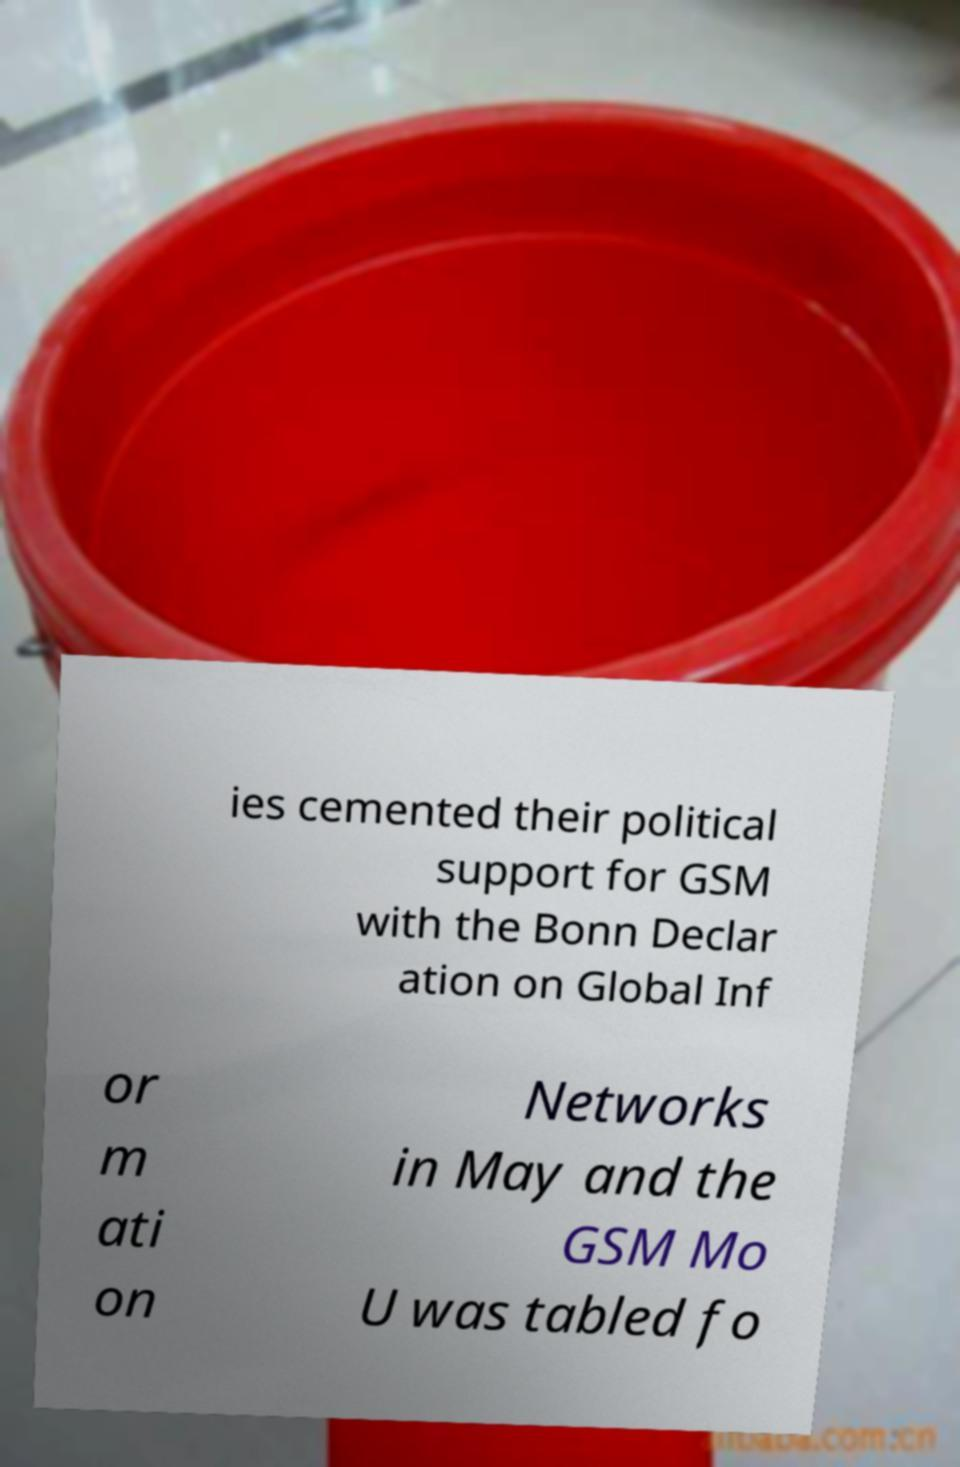For documentation purposes, I need the text within this image transcribed. Could you provide that? ies cemented their political support for GSM with the Bonn Declar ation on Global Inf or m ati on Networks in May and the GSM Mo U was tabled fo 